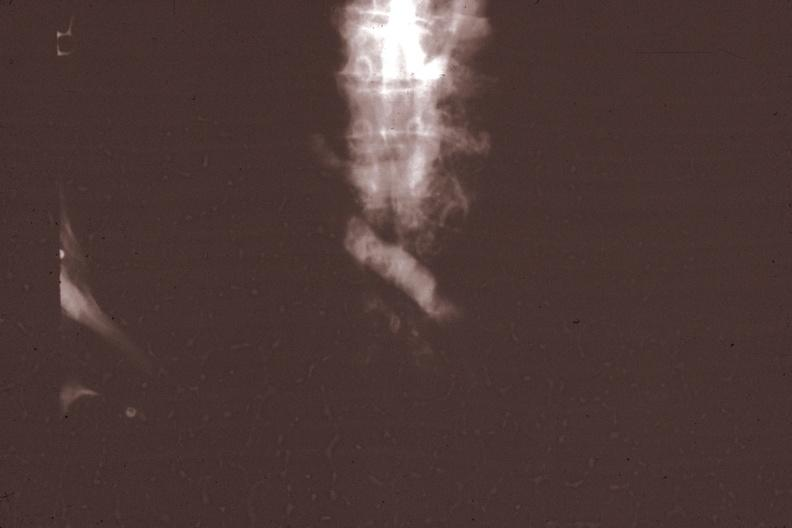s malignant thymoma present?
Answer the question using a single word or phrase. Yes 